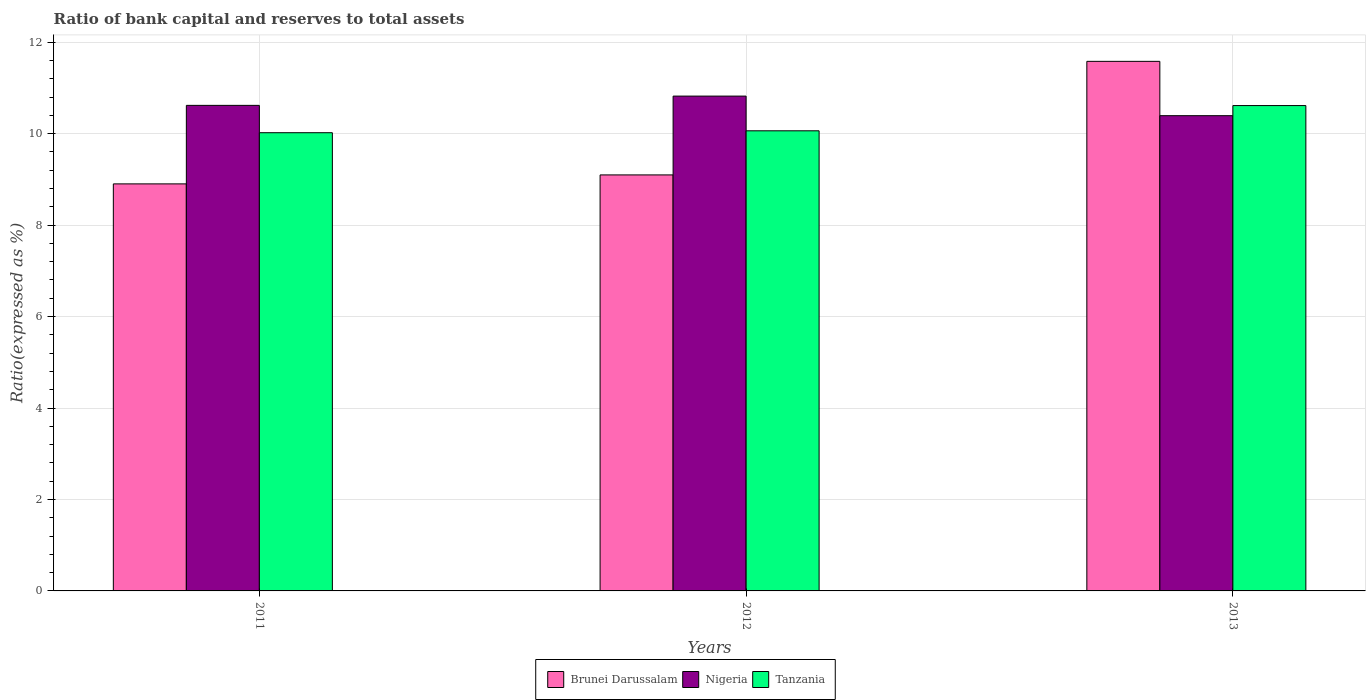How many groups of bars are there?
Make the answer very short. 3. Are the number of bars per tick equal to the number of legend labels?
Provide a succinct answer. Yes. How many bars are there on the 3rd tick from the right?
Make the answer very short. 3. What is the label of the 3rd group of bars from the left?
Provide a short and direct response. 2013. In how many cases, is the number of bars for a given year not equal to the number of legend labels?
Make the answer very short. 0. What is the ratio of bank capital and reserves to total assets in Brunei Darussalam in 2012?
Offer a very short reply. 9.1. Across all years, what is the maximum ratio of bank capital and reserves to total assets in Nigeria?
Your answer should be very brief. 10.82. Across all years, what is the minimum ratio of bank capital and reserves to total assets in Tanzania?
Offer a very short reply. 10.02. In which year was the ratio of bank capital and reserves to total assets in Brunei Darussalam minimum?
Your answer should be very brief. 2011. What is the total ratio of bank capital and reserves to total assets in Nigeria in the graph?
Provide a short and direct response. 31.83. What is the difference between the ratio of bank capital and reserves to total assets in Nigeria in 2011 and that in 2013?
Keep it short and to the point. 0.23. What is the difference between the ratio of bank capital and reserves to total assets in Tanzania in 2011 and the ratio of bank capital and reserves to total assets in Brunei Darussalam in 2013?
Your answer should be very brief. -1.56. What is the average ratio of bank capital and reserves to total assets in Nigeria per year?
Your response must be concise. 10.61. In the year 2013, what is the difference between the ratio of bank capital and reserves to total assets in Brunei Darussalam and ratio of bank capital and reserves to total assets in Tanzania?
Provide a succinct answer. 0.97. In how many years, is the ratio of bank capital and reserves to total assets in Brunei Darussalam greater than 2 %?
Offer a terse response. 3. What is the ratio of the ratio of bank capital and reserves to total assets in Brunei Darussalam in 2011 to that in 2013?
Your answer should be compact. 0.77. Is the ratio of bank capital and reserves to total assets in Nigeria in 2012 less than that in 2013?
Your response must be concise. No. What is the difference between the highest and the second highest ratio of bank capital and reserves to total assets in Tanzania?
Your answer should be very brief. 0.55. What is the difference between the highest and the lowest ratio of bank capital and reserves to total assets in Brunei Darussalam?
Give a very brief answer. 2.68. What does the 2nd bar from the left in 2013 represents?
Provide a succinct answer. Nigeria. What does the 1st bar from the right in 2013 represents?
Provide a short and direct response. Tanzania. Are all the bars in the graph horizontal?
Make the answer very short. No. How many years are there in the graph?
Keep it short and to the point. 3. What is the difference between two consecutive major ticks on the Y-axis?
Your response must be concise. 2. Are the values on the major ticks of Y-axis written in scientific E-notation?
Provide a succinct answer. No. Does the graph contain any zero values?
Make the answer very short. No. How are the legend labels stacked?
Your answer should be very brief. Horizontal. What is the title of the graph?
Give a very brief answer. Ratio of bank capital and reserves to total assets. Does "Central Europe" appear as one of the legend labels in the graph?
Ensure brevity in your answer.  No. What is the label or title of the Y-axis?
Ensure brevity in your answer.  Ratio(expressed as %). What is the Ratio(expressed as %) in Brunei Darussalam in 2011?
Your response must be concise. 8.9. What is the Ratio(expressed as %) of Nigeria in 2011?
Your answer should be very brief. 10.62. What is the Ratio(expressed as %) of Tanzania in 2011?
Give a very brief answer. 10.02. What is the Ratio(expressed as %) of Brunei Darussalam in 2012?
Your response must be concise. 9.1. What is the Ratio(expressed as %) of Nigeria in 2012?
Your response must be concise. 10.82. What is the Ratio(expressed as %) in Tanzania in 2012?
Your answer should be compact. 10.06. What is the Ratio(expressed as %) of Brunei Darussalam in 2013?
Offer a very short reply. 11.58. What is the Ratio(expressed as %) of Nigeria in 2013?
Your answer should be very brief. 10.39. What is the Ratio(expressed as %) of Tanzania in 2013?
Give a very brief answer. 10.61. Across all years, what is the maximum Ratio(expressed as %) in Brunei Darussalam?
Your response must be concise. 11.58. Across all years, what is the maximum Ratio(expressed as %) of Nigeria?
Offer a terse response. 10.82. Across all years, what is the maximum Ratio(expressed as %) of Tanzania?
Offer a very short reply. 10.61. Across all years, what is the minimum Ratio(expressed as %) in Brunei Darussalam?
Ensure brevity in your answer.  8.9. Across all years, what is the minimum Ratio(expressed as %) of Nigeria?
Offer a very short reply. 10.39. Across all years, what is the minimum Ratio(expressed as %) of Tanzania?
Offer a very short reply. 10.02. What is the total Ratio(expressed as %) in Brunei Darussalam in the graph?
Your answer should be very brief. 29.58. What is the total Ratio(expressed as %) of Nigeria in the graph?
Your response must be concise. 31.83. What is the total Ratio(expressed as %) of Tanzania in the graph?
Offer a terse response. 30.7. What is the difference between the Ratio(expressed as %) in Brunei Darussalam in 2011 and that in 2012?
Your answer should be very brief. -0.2. What is the difference between the Ratio(expressed as %) of Nigeria in 2011 and that in 2012?
Provide a short and direct response. -0.2. What is the difference between the Ratio(expressed as %) of Tanzania in 2011 and that in 2012?
Make the answer very short. -0.04. What is the difference between the Ratio(expressed as %) of Brunei Darussalam in 2011 and that in 2013?
Offer a very short reply. -2.68. What is the difference between the Ratio(expressed as %) of Nigeria in 2011 and that in 2013?
Provide a succinct answer. 0.23. What is the difference between the Ratio(expressed as %) of Tanzania in 2011 and that in 2013?
Ensure brevity in your answer.  -0.59. What is the difference between the Ratio(expressed as %) of Brunei Darussalam in 2012 and that in 2013?
Ensure brevity in your answer.  -2.48. What is the difference between the Ratio(expressed as %) of Nigeria in 2012 and that in 2013?
Offer a very short reply. 0.43. What is the difference between the Ratio(expressed as %) in Tanzania in 2012 and that in 2013?
Your response must be concise. -0.55. What is the difference between the Ratio(expressed as %) of Brunei Darussalam in 2011 and the Ratio(expressed as %) of Nigeria in 2012?
Your response must be concise. -1.92. What is the difference between the Ratio(expressed as %) of Brunei Darussalam in 2011 and the Ratio(expressed as %) of Tanzania in 2012?
Offer a terse response. -1.16. What is the difference between the Ratio(expressed as %) of Nigeria in 2011 and the Ratio(expressed as %) of Tanzania in 2012?
Provide a succinct answer. 0.56. What is the difference between the Ratio(expressed as %) in Brunei Darussalam in 2011 and the Ratio(expressed as %) in Nigeria in 2013?
Your answer should be compact. -1.49. What is the difference between the Ratio(expressed as %) in Brunei Darussalam in 2011 and the Ratio(expressed as %) in Tanzania in 2013?
Your answer should be very brief. -1.71. What is the difference between the Ratio(expressed as %) in Nigeria in 2011 and the Ratio(expressed as %) in Tanzania in 2013?
Your response must be concise. 0. What is the difference between the Ratio(expressed as %) in Brunei Darussalam in 2012 and the Ratio(expressed as %) in Nigeria in 2013?
Provide a short and direct response. -1.3. What is the difference between the Ratio(expressed as %) of Brunei Darussalam in 2012 and the Ratio(expressed as %) of Tanzania in 2013?
Your answer should be very brief. -1.52. What is the difference between the Ratio(expressed as %) in Nigeria in 2012 and the Ratio(expressed as %) in Tanzania in 2013?
Provide a short and direct response. 0.21. What is the average Ratio(expressed as %) in Brunei Darussalam per year?
Give a very brief answer. 9.86. What is the average Ratio(expressed as %) in Nigeria per year?
Keep it short and to the point. 10.61. What is the average Ratio(expressed as %) of Tanzania per year?
Ensure brevity in your answer.  10.23. In the year 2011, what is the difference between the Ratio(expressed as %) of Brunei Darussalam and Ratio(expressed as %) of Nigeria?
Offer a very short reply. -1.72. In the year 2011, what is the difference between the Ratio(expressed as %) of Brunei Darussalam and Ratio(expressed as %) of Tanzania?
Give a very brief answer. -1.12. In the year 2011, what is the difference between the Ratio(expressed as %) in Nigeria and Ratio(expressed as %) in Tanzania?
Make the answer very short. 0.6. In the year 2012, what is the difference between the Ratio(expressed as %) of Brunei Darussalam and Ratio(expressed as %) of Nigeria?
Your answer should be compact. -1.72. In the year 2012, what is the difference between the Ratio(expressed as %) in Brunei Darussalam and Ratio(expressed as %) in Tanzania?
Give a very brief answer. -0.96. In the year 2012, what is the difference between the Ratio(expressed as %) of Nigeria and Ratio(expressed as %) of Tanzania?
Your answer should be very brief. 0.76. In the year 2013, what is the difference between the Ratio(expressed as %) of Brunei Darussalam and Ratio(expressed as %) of Nigeria?
Ensure brevity in your answer.  1.19. In the year 2013, what is the difference between the Ratio(expressed as %) of Brunei Darussalam and Ratio(expressed as %) of Tanzania?
Keep it short and to the point. 0.97. In the year 2013, what is the difference between the Ratio(expressed as %) of Nigeria and Ratio(expressed as %) of Tanzania?
Keep it short and to the point. -0.22. What is the ratio of the Ratio(expressed as %) in Brunei Darussalam in 2011 to that in 2012?
Ensure brevity in your answer.  0.98. What is the ratio of the Ratio(expressed as %) of Nigeria in 2011 to that in 2012?
Make the answer very short. 0.98. What is the ratio of the Ratio(expressed as %) of Tanzania in 2011 to that in 2012?
Keep it short and to the point. 1. What is the ratio of the Ratio(expressed as %) in Brunei Darussalam in 2011 to that in 2013?
Give a very brief answer. 0.77. What is the ratio of the Ratio(expressed as %) in Nigeria in 2011 to that in 2013?
Ensure brevity in your answer.  1.02. What is the ratio of the Ratio(expressed as %) of Tanzania in 2011 to that in 2013?
Offer a terse response. 0.94. What is the ratio of the Ratio(expressed as %) of Brunei Darussalam in 2012 to that in 2013?
Provide a short and direct response. 0.79. What is the ratio of the Ratio(expressed as %) in Nigeria in 2012 to that in 2013?
Give a very brief answer. 1.04. What is the ratio of the Ratio(expressed as %) in Tanzania in 2012 to that in 2013?
Provide a short and direct response. 0.95. What is the difference between the highest and the second highest Ratio(expressed as %) in Brunei Darussalam?
Your answer should be compact. 2.48. What is the difference between the highest and the second highest Ratio(expressed as %) of Nigeria?
Keep it short and to the point. 0.2. What is the difference between the highest and the second highest Ratio(expressed as %) in Tanzania?
Keep it short and to the point. 0.55. What is the difference between the highest and the lowest Ratio(expressed as %) in Brunei Darussalam?
Your answer should be very brief. 2.68. What is the difference between the highest and the lowest Ratio(expressed as %) of Nigeria?
Give a very brief answer. 0.43. What is the difference between the highest and the lowest Ratio(expressed as %) of Tanzania?
Your answer should be compact. 0.59. 